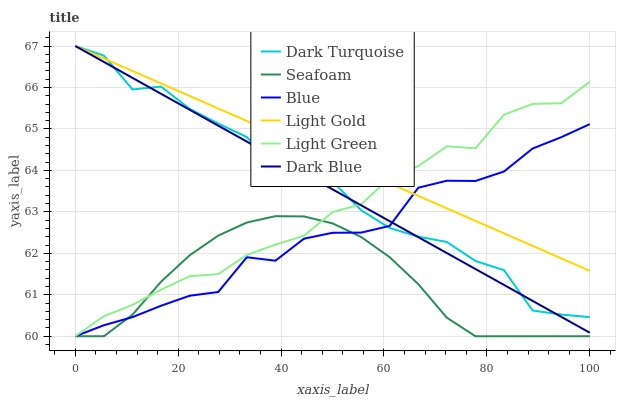Does Dark Turquoise have the minimum area under the curve?
Answer yes or no. No. Does Dark Turquoise have the maximum area under the curve?
Answer yes or no. No. Is Seafoam the smoothest?
Answer yes or no. No. Is Seafoam the roughest?
Answer yes or no. No. Does Dark Turquoise have the lowest value?
Answer yes or no. No. Does Seafoam have the highest value?
Answer yes or no. No. Is Seafoam less than Dark Blue?
Answer yes or no. Yes. Is Dark Turquoise greater than Seafoam?
Answer yes or no. Yes. Does Seafoam intersect Dark Blue?
Answer yes or no. No. 